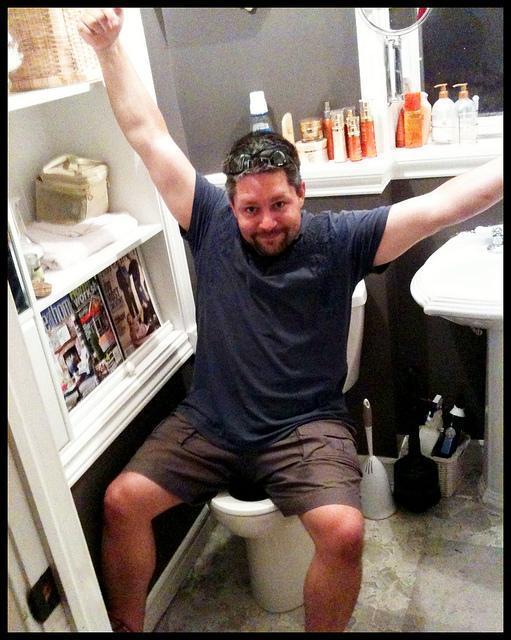How many books are in the picture?
Give a very brief answer. 3. How many horses are brown?
Give a very brief answer. 0. 